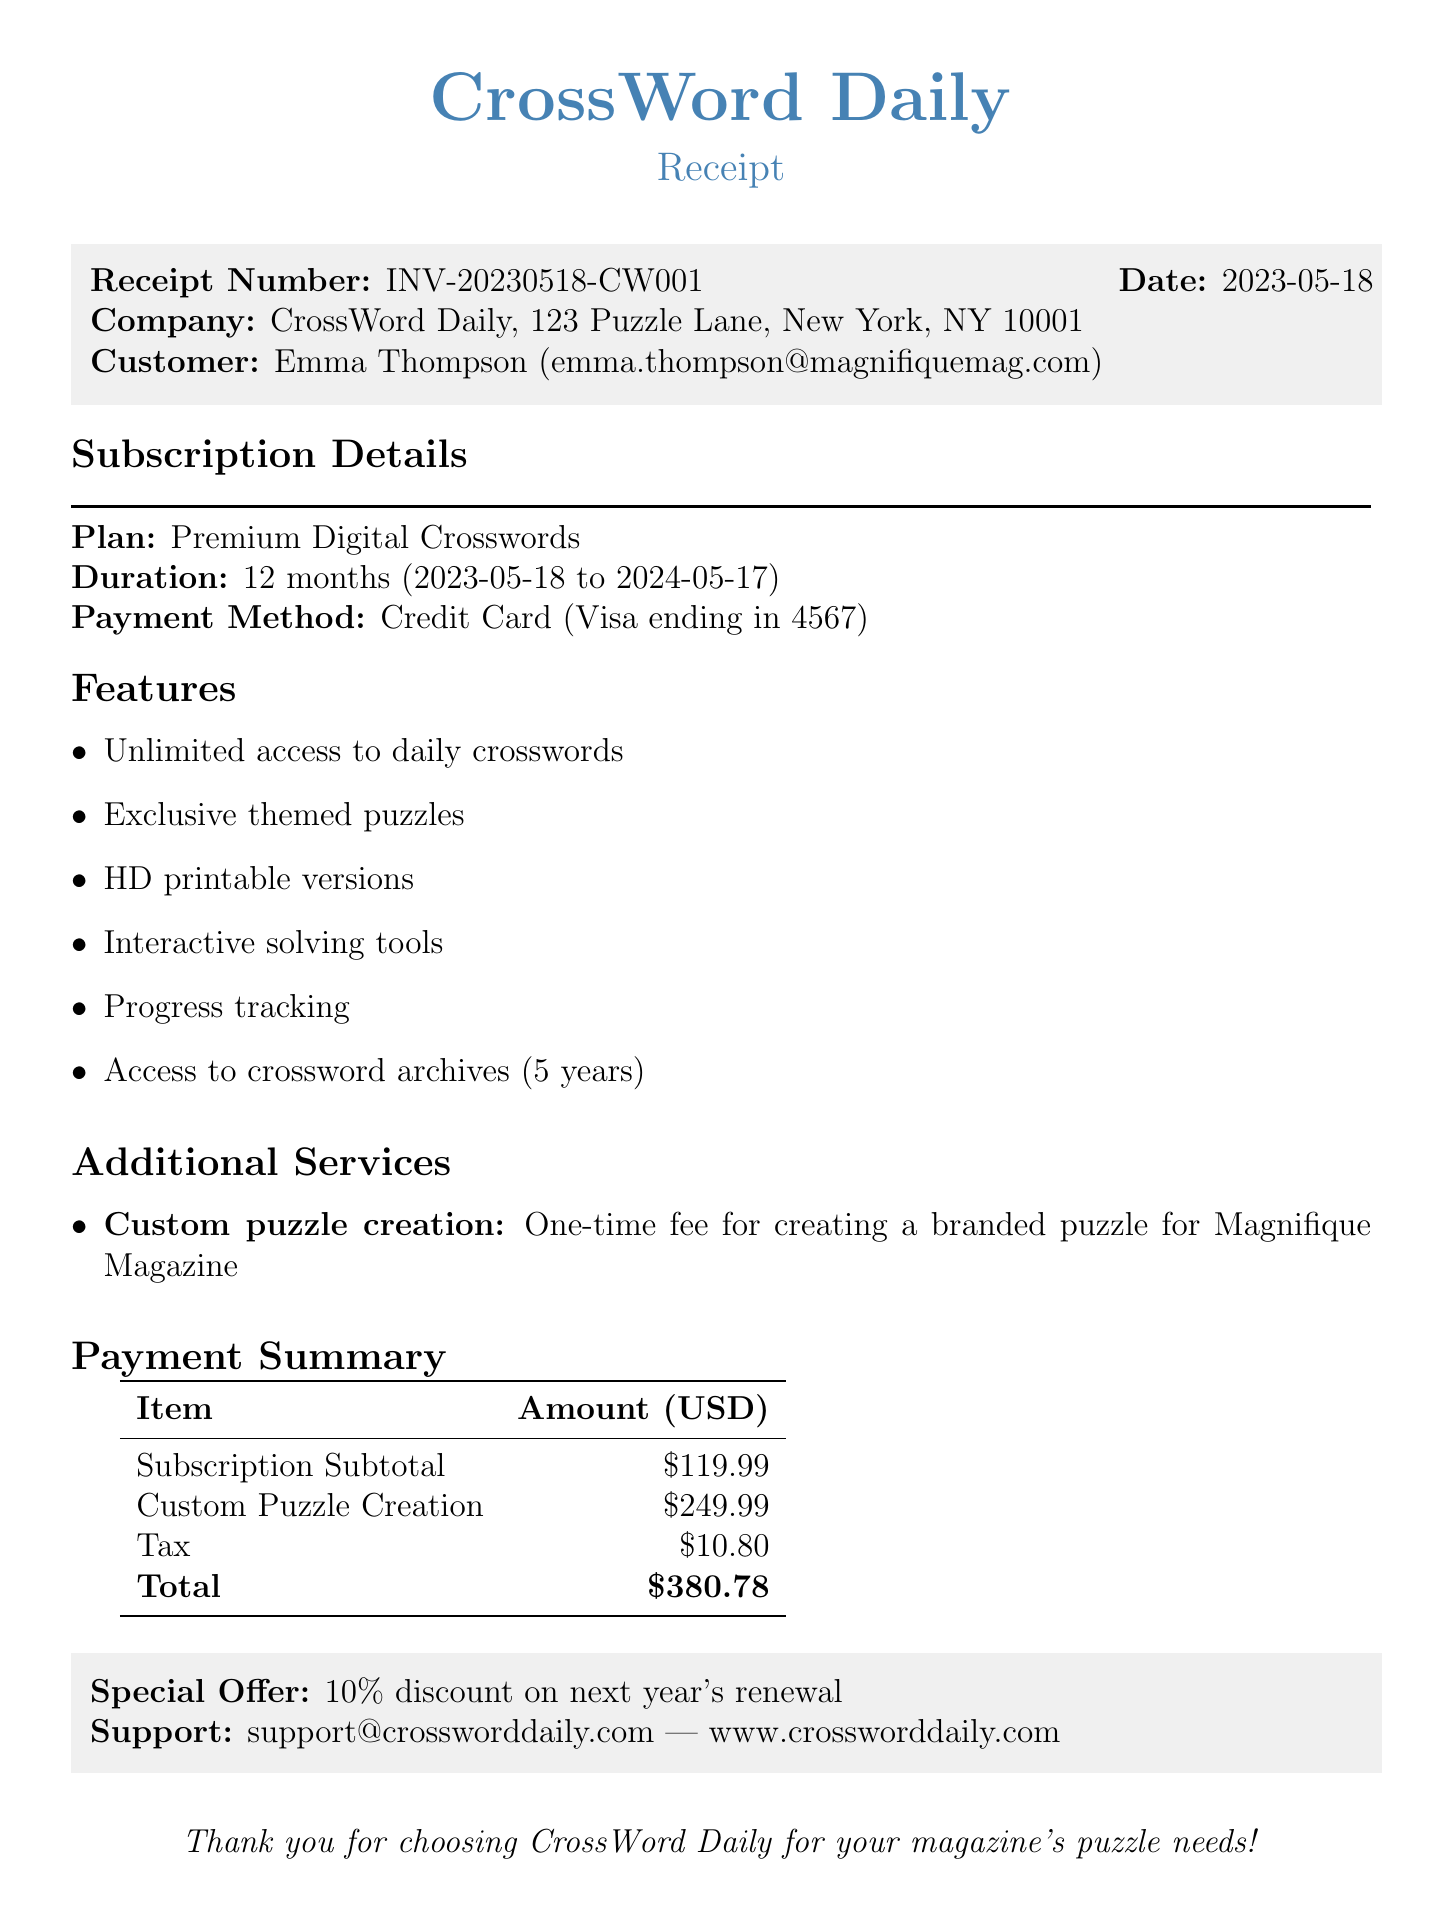What is the receipt number? The receipt number is the unique identifier for the transaction, indicated in the document as INV-20230518-CW001.
Answer: INV-20230518-CW001 What is the date of the transaction? The date of the transaction is clearly stated in the document, marked as 2023-05-18.
Answer: 2023-05-18 Who is the customer? The customer is identified in the document, which specifies her name as Emma Thompson.
Answer: Emma Thompson What is the duration of the subscription? The duration of the subscription is noted in the document as 12 months.
Answer: 12 months What payment method was used? The payment method is described in the document as Credit Card (Visa ending in 4567).
Answer: Credit Card (Visa ending in 4567) What is the total amount due? The total amount due is the sum of the subscription subtotal, any additional charges, and tax, which is stated as $130.79.
Answer: $130.79 What special offer is mentioned? The document includes a special offer related to subscription renewal, specified as a 10% discount on next year's renewal.
Answer: 10% discount on next year's renewal What additional service is offered? The document lists an additional service with a description, namely custom puzzle creation for a one-time fee.
Answer: Custom puzzle creation What is the support email provided? The support email is provided in the document for customer assistance, which is support@crossworddaily.com.
Answer: support@crossworddaily.com When does the subscription end? The end date of the subscription is mentioned in the document as 2024-05-17.
Answer: 2024-05-17 